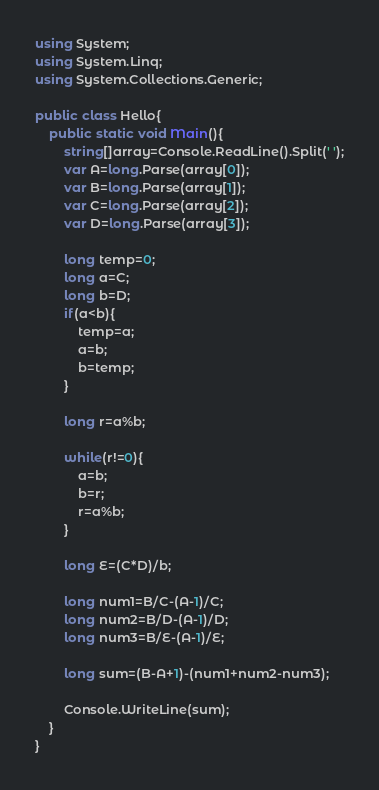<code> <loc_0><loc_0><loc_500><loc_500><_C#_>using System;
using System.Linq;
using System.Collections.Generic;

public class Hello{
    public static void Main(){
        string[]array=Console.ReadLine().Split(' ');
        var A=long.Parse(array[0]);
        var B=long.Parse(array[1]);
        var C=long.Parse(array[2]);
        var D=long.Parse(array[3]);
        
        long temp=0;
        long a=C;
        long b=D;
        if(a<b){
            temp=a;
            a=b;
            b=temp;
        }
        
        long r=a%b;
        
        while(r!=0){
            a=b;
            b=r;
            r=a%b;
        }
        
        long E=(C*D)/b;
        
        long num1=B/C-(A-1)/C;
        long num2=B/D-(A-1)/D;
        long num3=B/E-(A-1)/E;
        
        long sum=(B-A+1)-(num1+num2-num3);
        
        Console.WriteLine(sum);
    }
}
</code> 